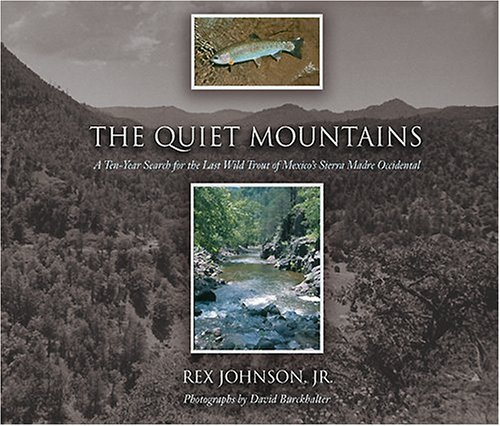Is this a comedy book? No, ‘The Quiet Mountains’ is not a comedy book; it is concerned with the natural world and trout fishing in the Sierra Madre Occidental. 